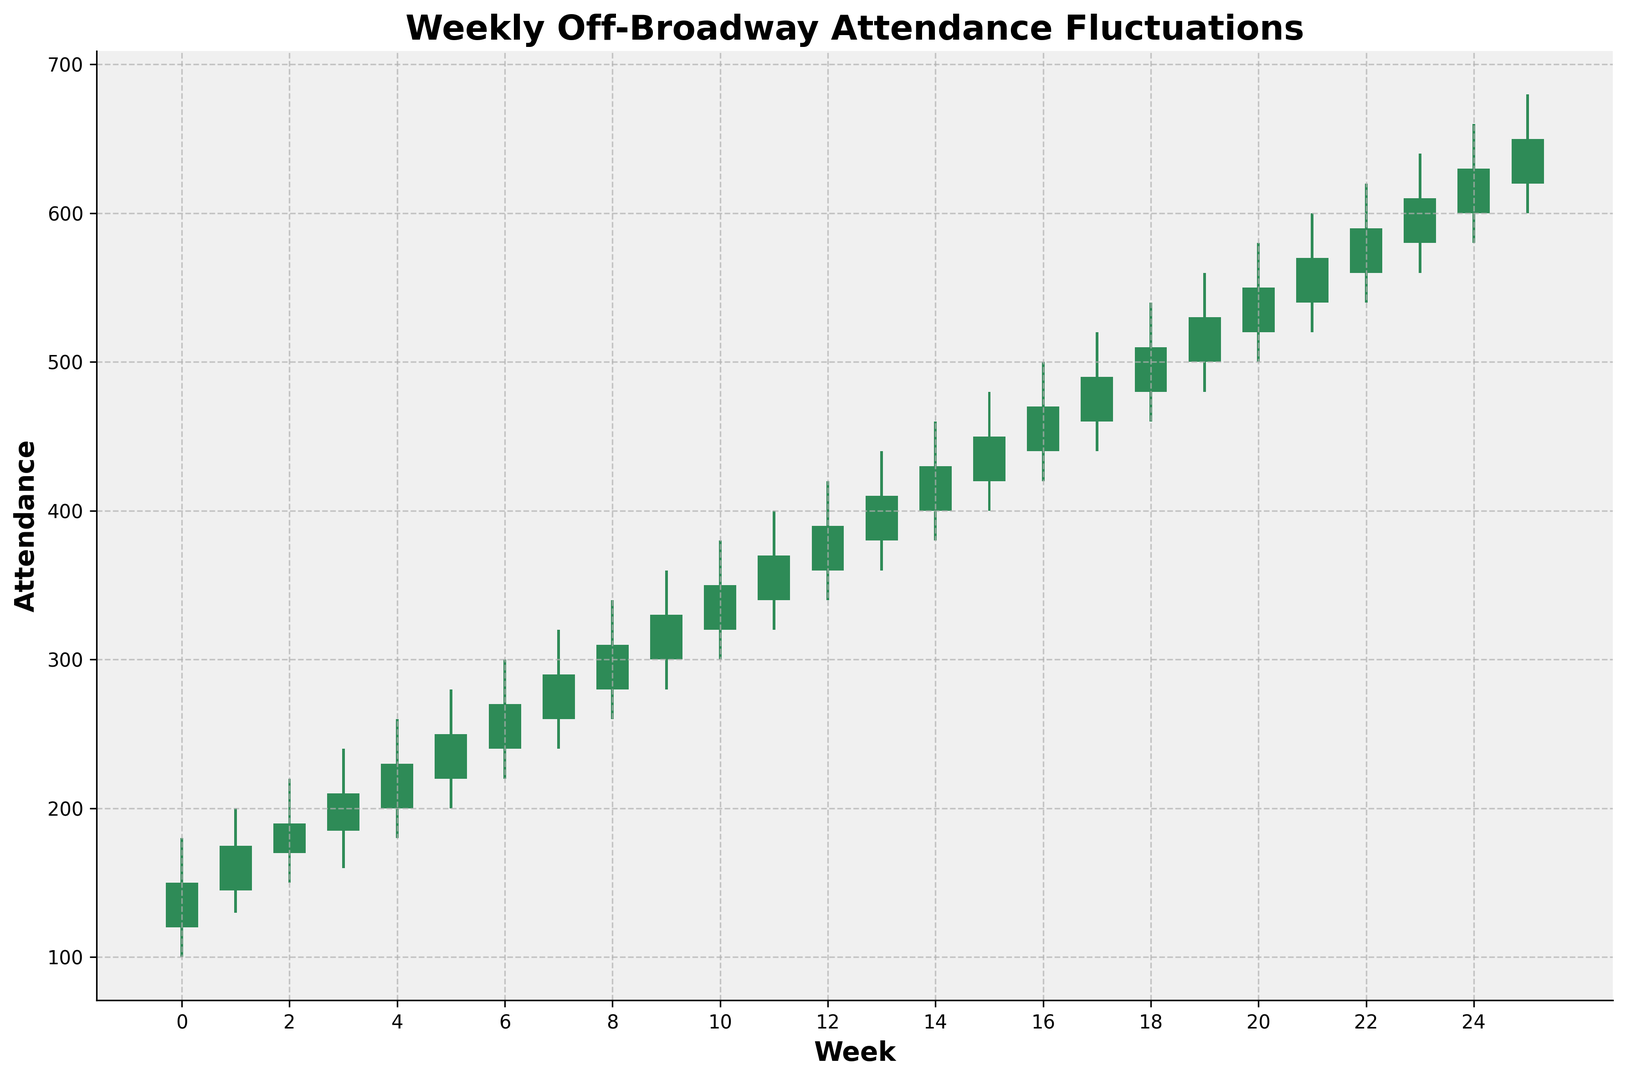What is the highest attendance recorded in any week? The highest attendance is represented by the tallest green bar, and it corresponds to the "High" value of the specific week. In this case, the highest attendance recorded is in Week 26, where the "High" value is 680.
Answer: 680 Which week shows the largest difference between the highest and lowest attendance? To find this, we need to look at the range of each week, which is the difference between the "High" and "Low" values. The week with the largest difference is Week 26, where the difference is 680 - 600 = 80.
Answer: Week 26 What is the average closing attendance for the first 10 weeks? To get the average closing attendance, sum the Close values for the first 10 weeks and divide by 10. The Close values are 150, 175, 190, 210, 230, 250, 270, 290, 310, and 330. Adding them yields 2405, so the average is 2405 / 10 = 240.5.
Answer: 240.5 Which week shows a decrease in attendance from open to close? A decrease in attendance occurs if the Close value is less than the Open value. None of the weeks show a decrease because all Close values are greater than their corresponding Open values.
Answer: None How does the attendance trend over the entire period? Is it generally increasing or decreasing? The general trend can be observed by connecting the Open or Close values over time. Here the attendance values (both Open and Close) show a consistent increase from Week 1 to Week 26.
Answer: Increasing 